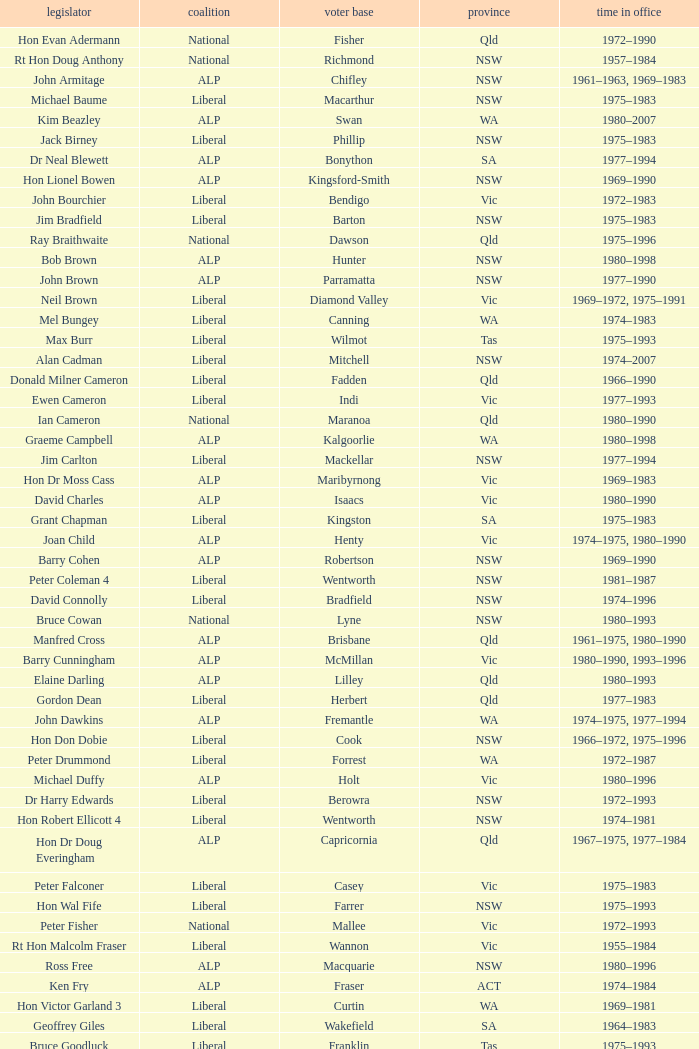What party is Mick Young a member of? ALP. 